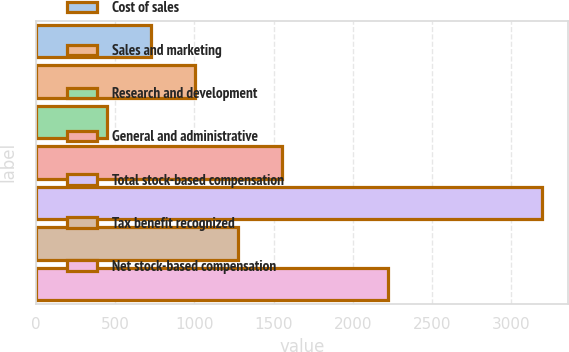<chart> <loc_0><loc_0><loc_500><loc_500><bar_chart><fcel>Cost of sales<fcel>Sales and marketing<fcel>Research and development<fcel>General and administrative<fcel>Total stock-based compensation<fcel>Tax benefit recognized<fcel>Net stock-based compensation<nl><fcel>727<fcel>1002<fcel>446<fcel>1552<fcel>3196<fcel>1277<fcel>2223<nl></chart> 